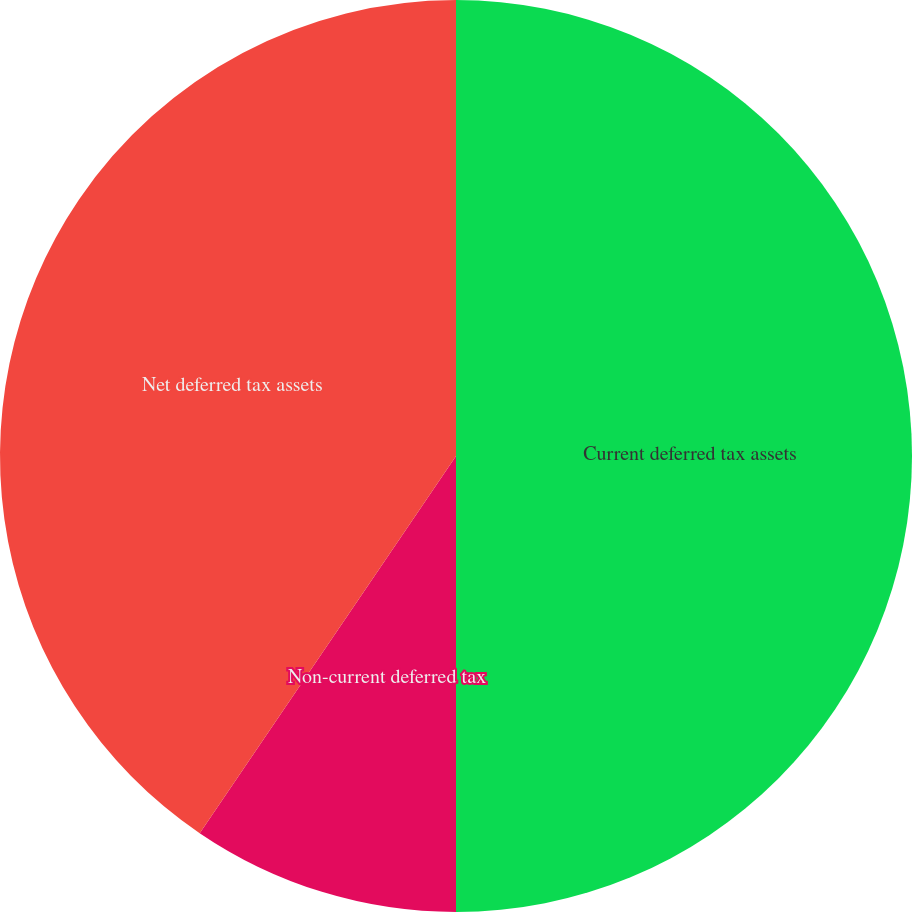Convert chart to OTSL. <chart><loc_0><loc_0><loc_500><loc_500><pie_chart><fcel>Current deferred tax assets<fcel>Non-current deferred tax<fcel>Net deferred tax assets<nl><fcel>50.0%<fcel>9.5%<fcel>40.5%<nl></chart> 